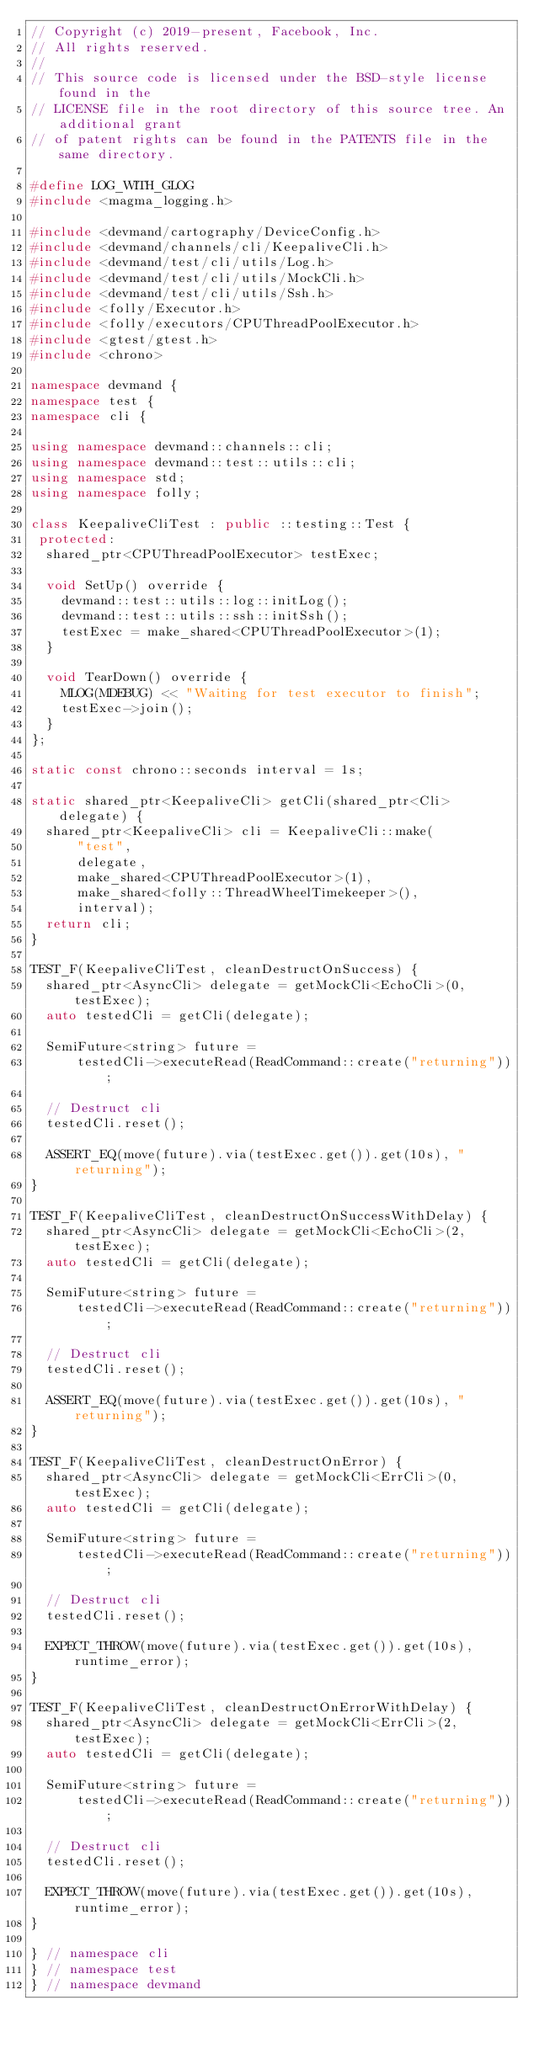Convert code to text. <code><loc_0><loc_0><loc_500><loc_500><_C++_>// Copyright (c) 2019-present, Facebook, Inc.
// All rights reserved.
//
// This source code is licensed under the BSD-style license found in the
// LICENSE file in the root directory of this source tree. An additional grant
// of patent rights can be found in the PATENTS file in the same directory.

#define LOG_WITH_GLOG
#include <magma_logging.h>

#include <devmand/cartography/DeviceConfig.h>
#include <devmand/channels/cli/KeepaliveCli.h>
#include <devmand/test/cli/utils/Log.h>
#include <devmand/test/cli/utils/MockCli.h>
#include <devmand/test/cli/utils/Ssh.h>
#include <folly/Executor.h>
#include <folly/executors/CPUThreadPoolExecutor.h>
#include <gtest/gtest.h>
#include <chrono>

namespace devmand {
namespace test {
namespace cli {

using namespace devmand::channels::cli;
using namespace devmand::test::utils::cli;
using namespace std;
using namespace folly;

class KeepaliveCliTest : public ::testing::Test {
 protected:
  shared_ptr<CPUThreadPoolExecutor> testExec;

  void SetUp() override {
    devmand::test::utils::log::initLog();
    devmand::test::utils::ssh::initSsh();
    testExec = make_shared<CPUThreadPoolExecutor>(1);
  }

  void TearDown() override {
    MLOG(MDEBUG) << "Waiting for test executor to finish";
    testExec->join();
  }
};

static const chrono::seconds interval = 1s;

static shared_ptr<KeepaliveCli> getCli(shared_ptr<Cli> delegate) {
  shared_ptr<KeepaliveCli> cli = KeepaliveCli::make(
      "test",
      delegate,
      make_shared<CPUThreadPoolExecutor>(1),
      make_shared<folly::ThreadWheelTimekeeper>(),
      interval);
  return cli;
}

TEST_F(KeepaliveCliTest, cleanDestructOnSuccess) {
  shared_ptr<AsyncCli> delegate = getMockCli<EchoCli>(0, testExec);
  auto testedCli = getCli(delegate);

  SemiFuture<string> future =
      testedCli->executeRead(ReadCommand::create("returning"));

  // Destruct cli
  testedCli.reset();

  ASSERT_EQ(move(future).via(testExec.get()).get(10s), "returning");
}

TEST_F(KeepaliveCliTest, cleanDestructOnSuccessWithDelay) {
  shared_ptr<AsyncCli> delegate = getMockCli<EchoCli>(2, testExec);
  auto testedCli = getCli(delegate);

  SemiFuture<string> future =
      testedCli->executeRead(ReadCommand::create("returning"));

  // Destruct cli
  testedCli.reset();

  ASSERT_EQ(move(future).via(testExec.get()).get(10s), "returning");
}

TEST_F(KeepaliveCliTest, cleanDestructOnError) {
  shared_ptr<AsyncCli> delegate = getMockCli<ErrCli>(0, testExec);
  auto testedCli = getCli(delegate);

  SemiFuture<string> future =
      testedCli->executeRead(ReadCommand::create("returning"));

  // Destruct cli
  testedCli.reset();

  EXPECT_THROW(move(future).via(testExec.get()).get(10s), runtime_error);
}

TEST_F(KeepaliveCliTest, cleanDestructOnErrorWithDelay) {
  shared_ptr<AsyncCli> delegate = getMockCli<ErrCli>(2, testExec);
  auto testedCli = getCli(delegate);

  SemiFuture<string> future =
      testedCli->executeRead(ReadCommand::create("returning"));

  // Destruct cli
  testedCli.reset();

  EXPECT_THROW(move(future).via(testExec.get()).get(10s), runtime_error);
}

} // namespace cli
} // namespace test
} // namespace devmand
</code> 